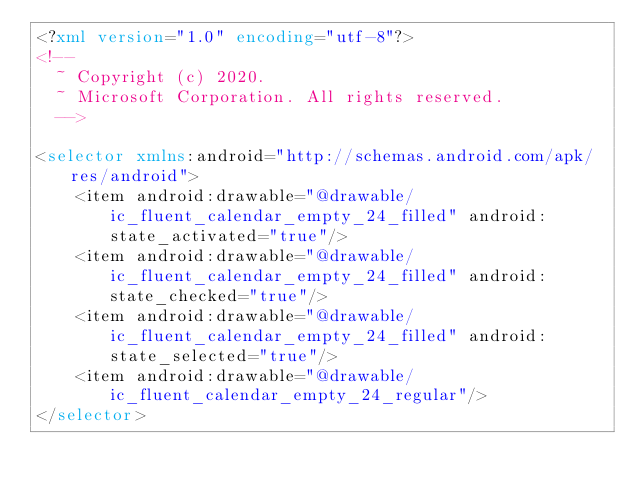Convert code to text. <code><loc_0><loc_0><loc_500><loc_500><_XML_><?xml version="1.0" encoding="utf-8"?>
<!--
  ~ Copyright (c) 2020.
  ~ Microsoft Corporation. All rights reserved.
  -->

<selector xmlns:android="http://schemas.android.com/apk/res/android">
    <item android:drawable="@drawable/ic_fluent_calendar_empty_24_filled" android:state_activated="true"/>
    <item android:drawable="@drawable/ic_fluent_calendar_empty_24_filled" android:state_checked="true"/>
    <item android:drawable="@drawable/ic_fluent_calendar_empty_24_filled" android:state_selected="true"/>
    <item android:drawable="@drawable/ic_fluent_calendar_empty_24_regular"/>
</selector>
</code> 